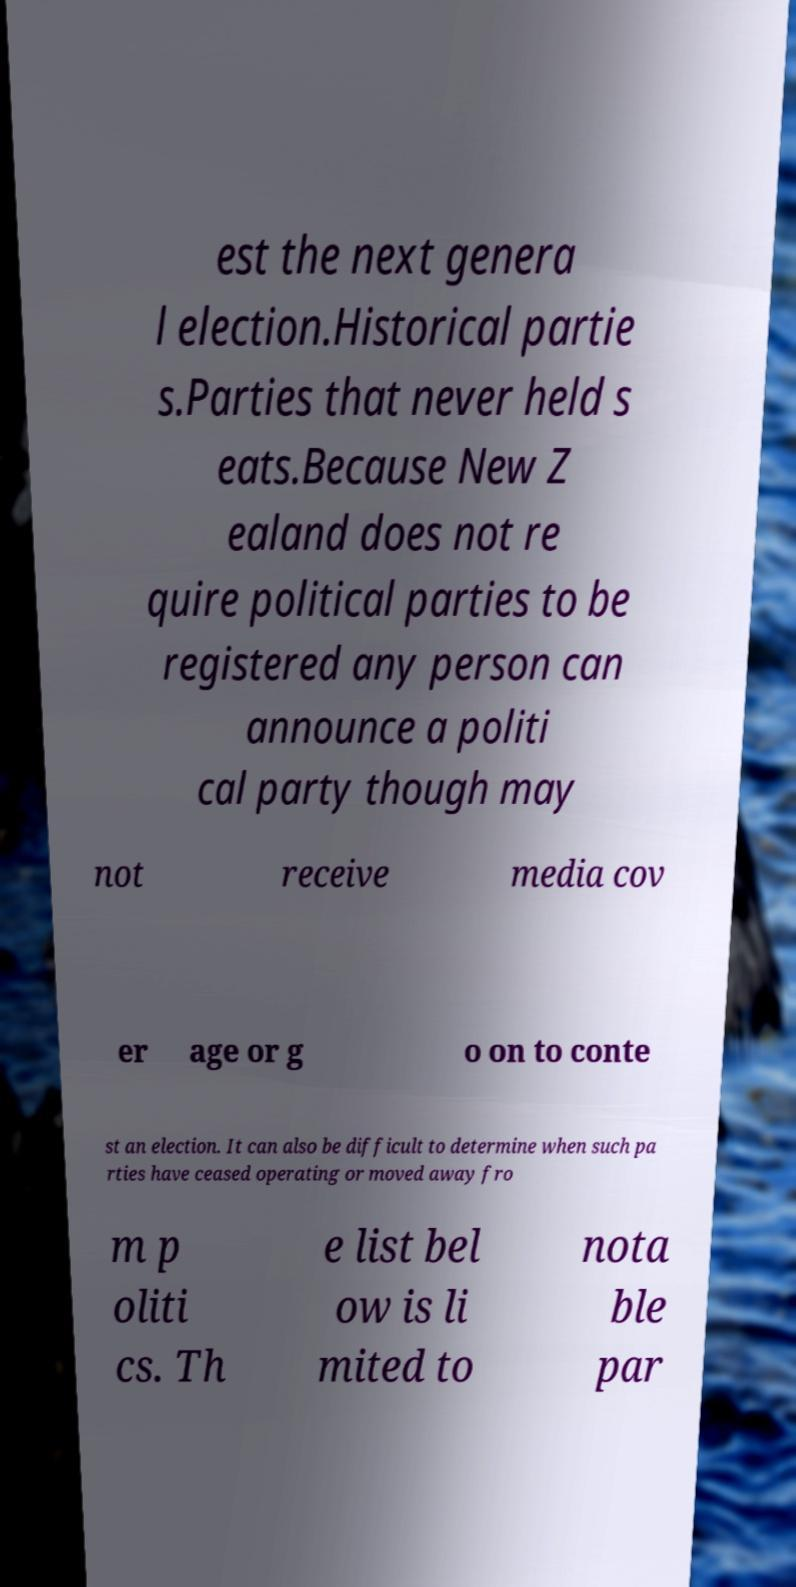What messages or text are displayed in this image? I need them in a readable, typed format. est the next genera l election.Historical partie s.Parties that never held s eats.Because New Z ealand does not re quire political parties to be registered any person can announce a politi cal party though may not receive media cov er age or g o on to conte st an election. It can also be difficult to determine when such pa rties have ceased operating or moved away fro m p oliti cs. Th e list bel ow is li mited to nota ble par 